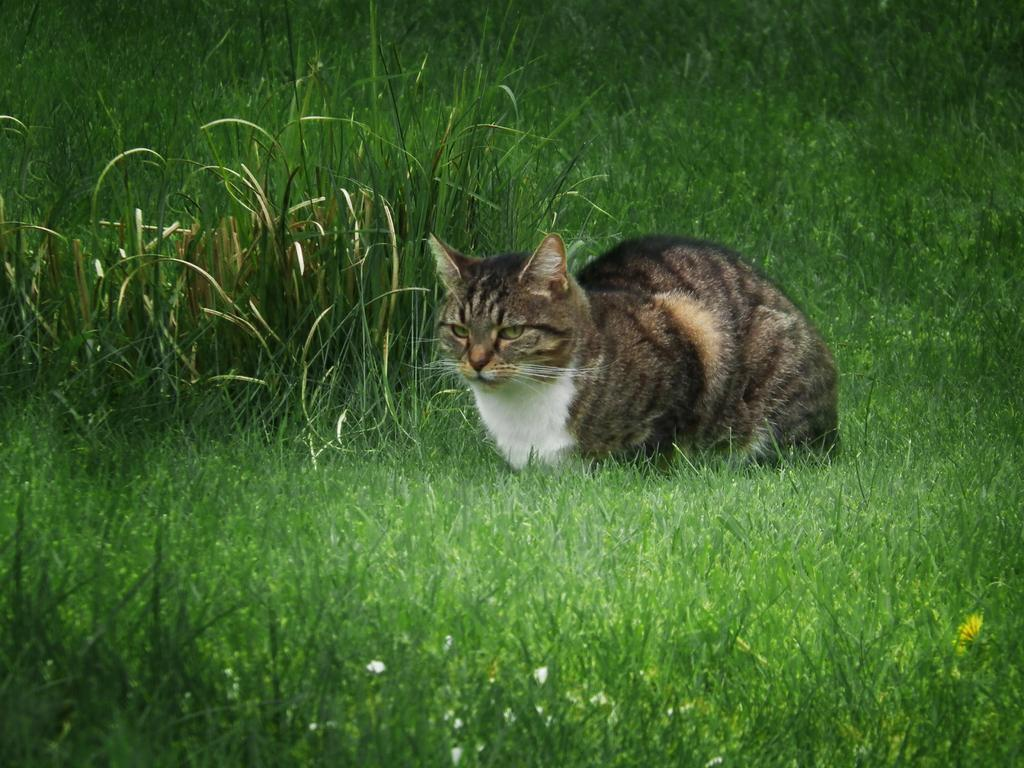What type of animal is in the image? There is a cat in the image. Where is the cat located? The cat is in the grass. What type of bag is the cat carrying in the image? There is no bag present in the image; the cat is simply in the grass. 